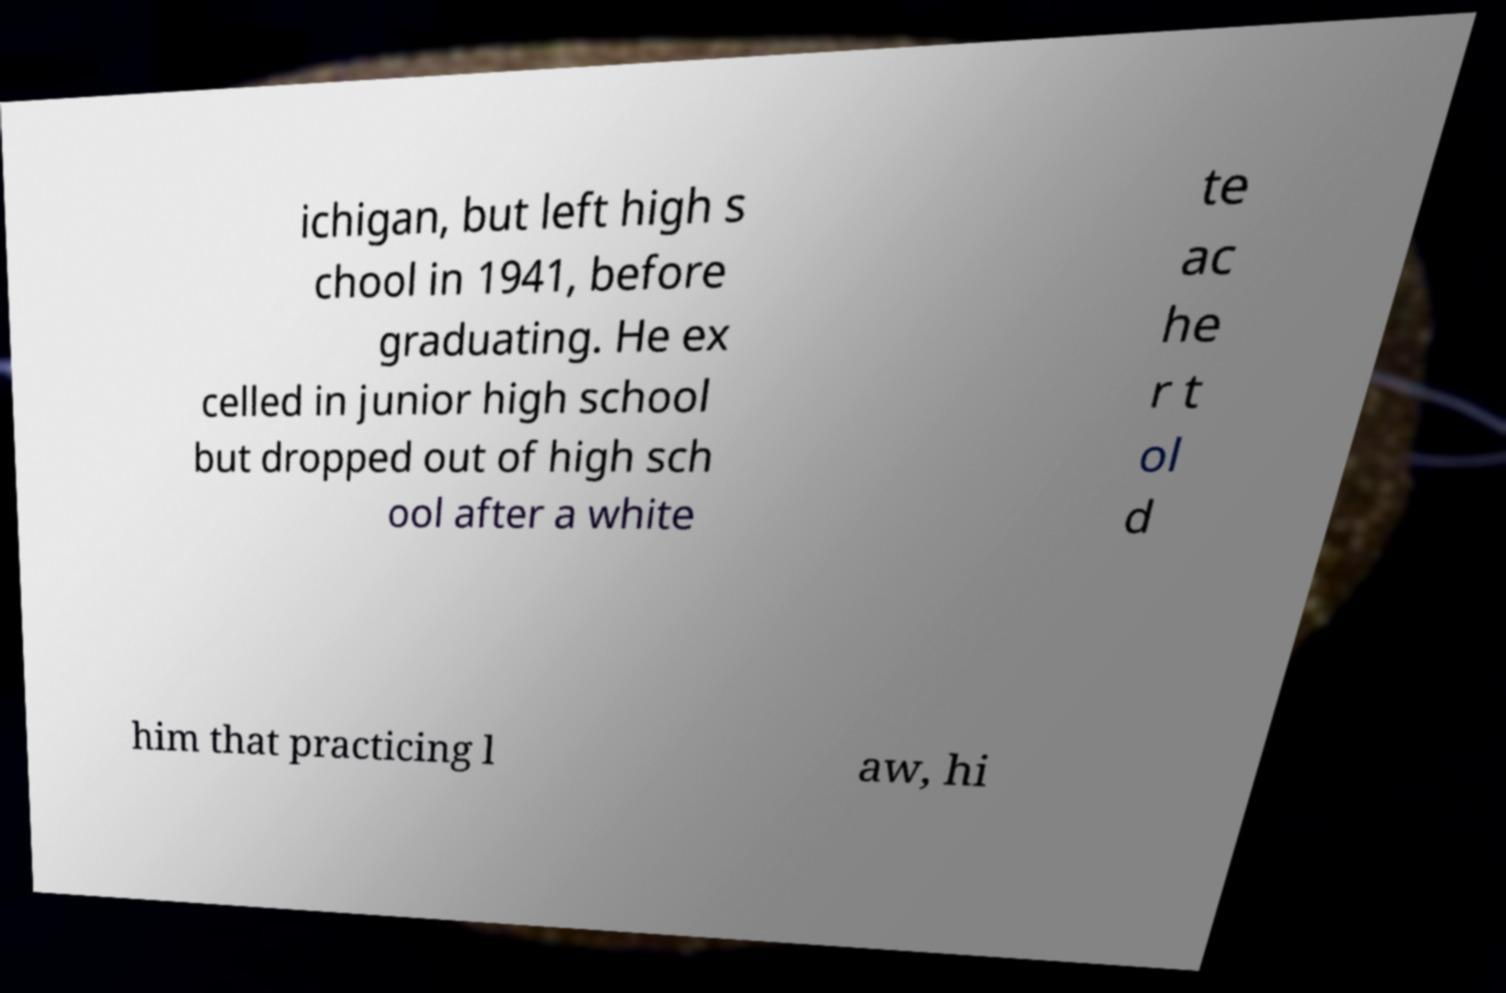I need the written content from this picture converted into text. Can you do that? ichigan, but left high s chool in 1941, before graduating. He ex celled in junior high school but dropped out of high sch ool after a white te ac he r t ol d him that practicing l aw, hi 